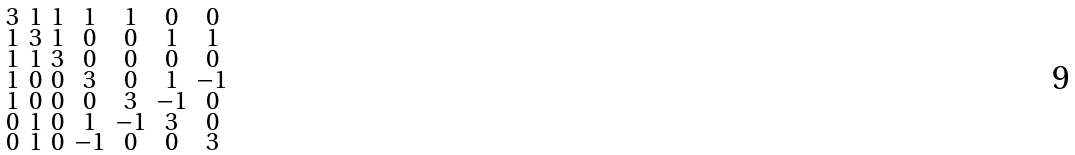<formula> <loc_0><loc_0><loc_500><loc_500>\begin{smallmatrix} 3 & 1 & 1 & 1 & 1 & 0 & 0 \\ 1 & 3 & 1 & 0 & 0 & 1 & 1 \\ 1 & 1 & 3 & 0 & 0 & 0 & 0 \\ 1 & 0 & 0 & 3 & 0 & 1 & - 1 \\ 1 & 0 & 0 & 0 & 3 & - 1 & 0 \\ 0 & 1 & 0 & 1 & - 1 & 3 & 0 \\ 0 & 1 & 0 & - 1 & 0 & 0 & 3 \end{smallmatrix}</formula> 